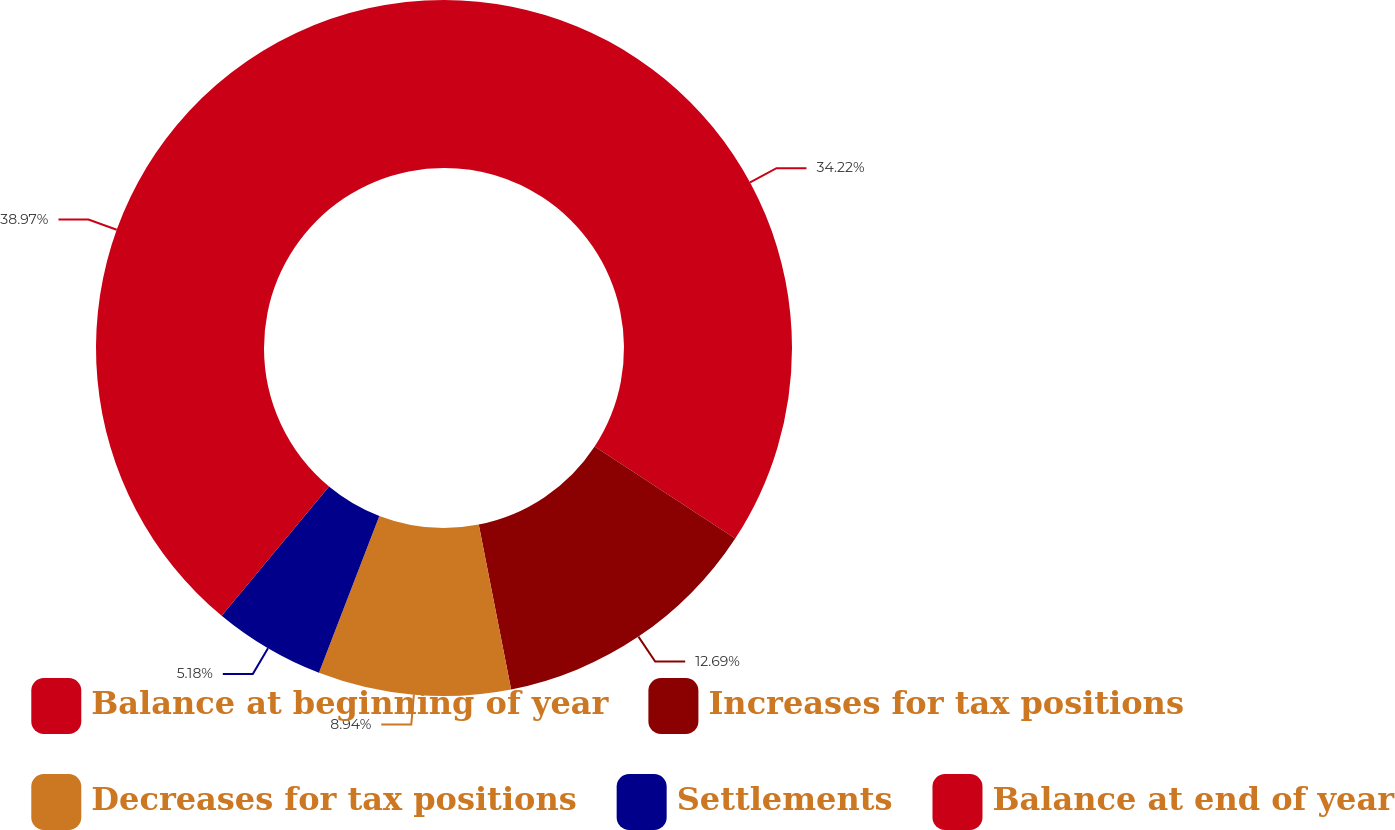Convert chart. <chart><loc_0><loc_0><loc_500><loc_500><pie_chart><fcel>Balance at beginning of year<fcel>Increases for tax positions<fcel>Decreases for tax positions<fcel>Settlements<fcel>Balance at end of year<nl><fcel>34.22%<fcel>12.69%<fcel>8.94%<fcel>5.18%<fcel>38.97%<nl></chart> 